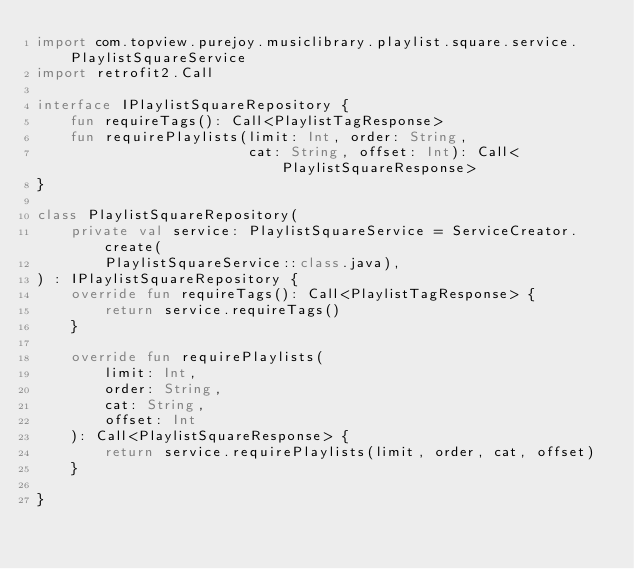Convert code to text. <code><loc_0><loc_0><loc_500><loc_500><_Kotlin_>import com.topview.purejoy.musiclibrary.playlist.square.service.PlaylistSquareService
import retrofit2.Call

interface IPlaylistSquareRepository {
    fun requireTags(): Call<PlaylistTagResponse>
    fun requirePlaylists(limit: Int, order: String,
                         cat: String, offset: Int): Call<PlaylistSquareResponse>
}

class PlaylistSquareRepository(
    private val service: PlaylistSquareService = ServiceCreator.create(
        PlaylistSquareService::class.java),
) : IPlaylistSquareRepository {
    override fun requireTags(): Call<PlaylistTagResponse> {
        return service.requireTags()
    }

    override fun requirePlaylists(
        limit: Int,
        order: String,
        cat: String,
        offset: Int
    ): Call<PlaylistSquareResponse> {
        return service.requirePlaylists(limit, order, cat, offset)
    }

}</code> 